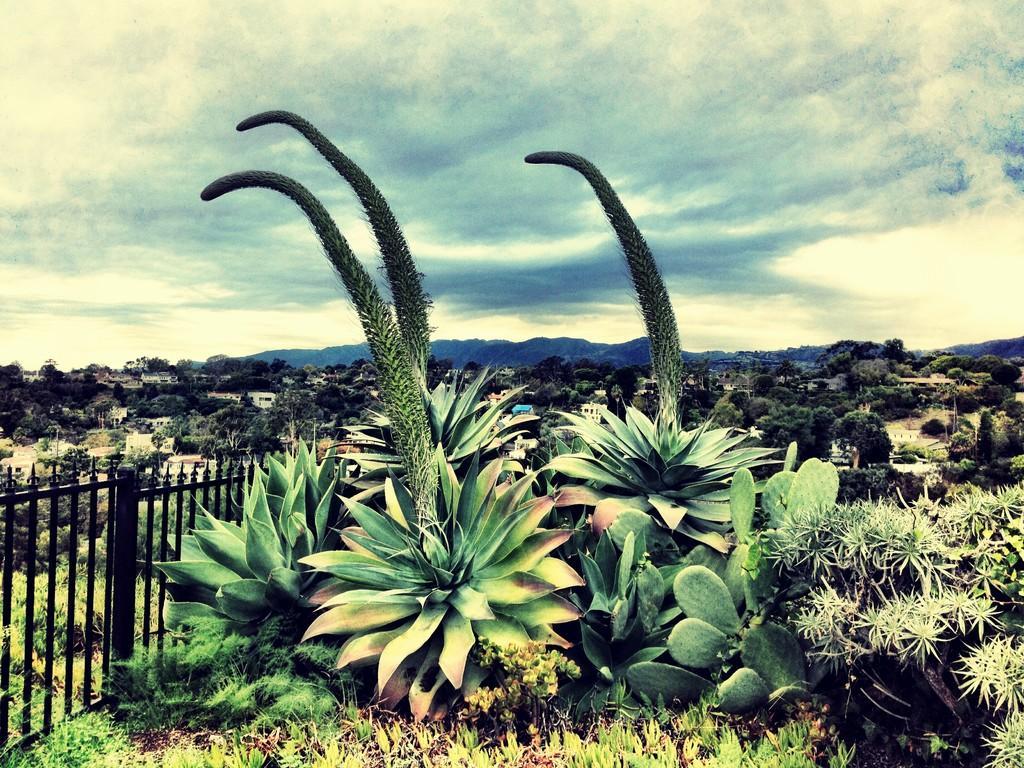In one or two sentences, can you explain what this image depicts? In this image, we can see some plants, grass, trees, houses, hills. We can see the fence and the sky with clouds. 